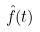<formula> <loc_0><loc_0><loc_500><loc_500>\hat { f } ( t )</formula> 